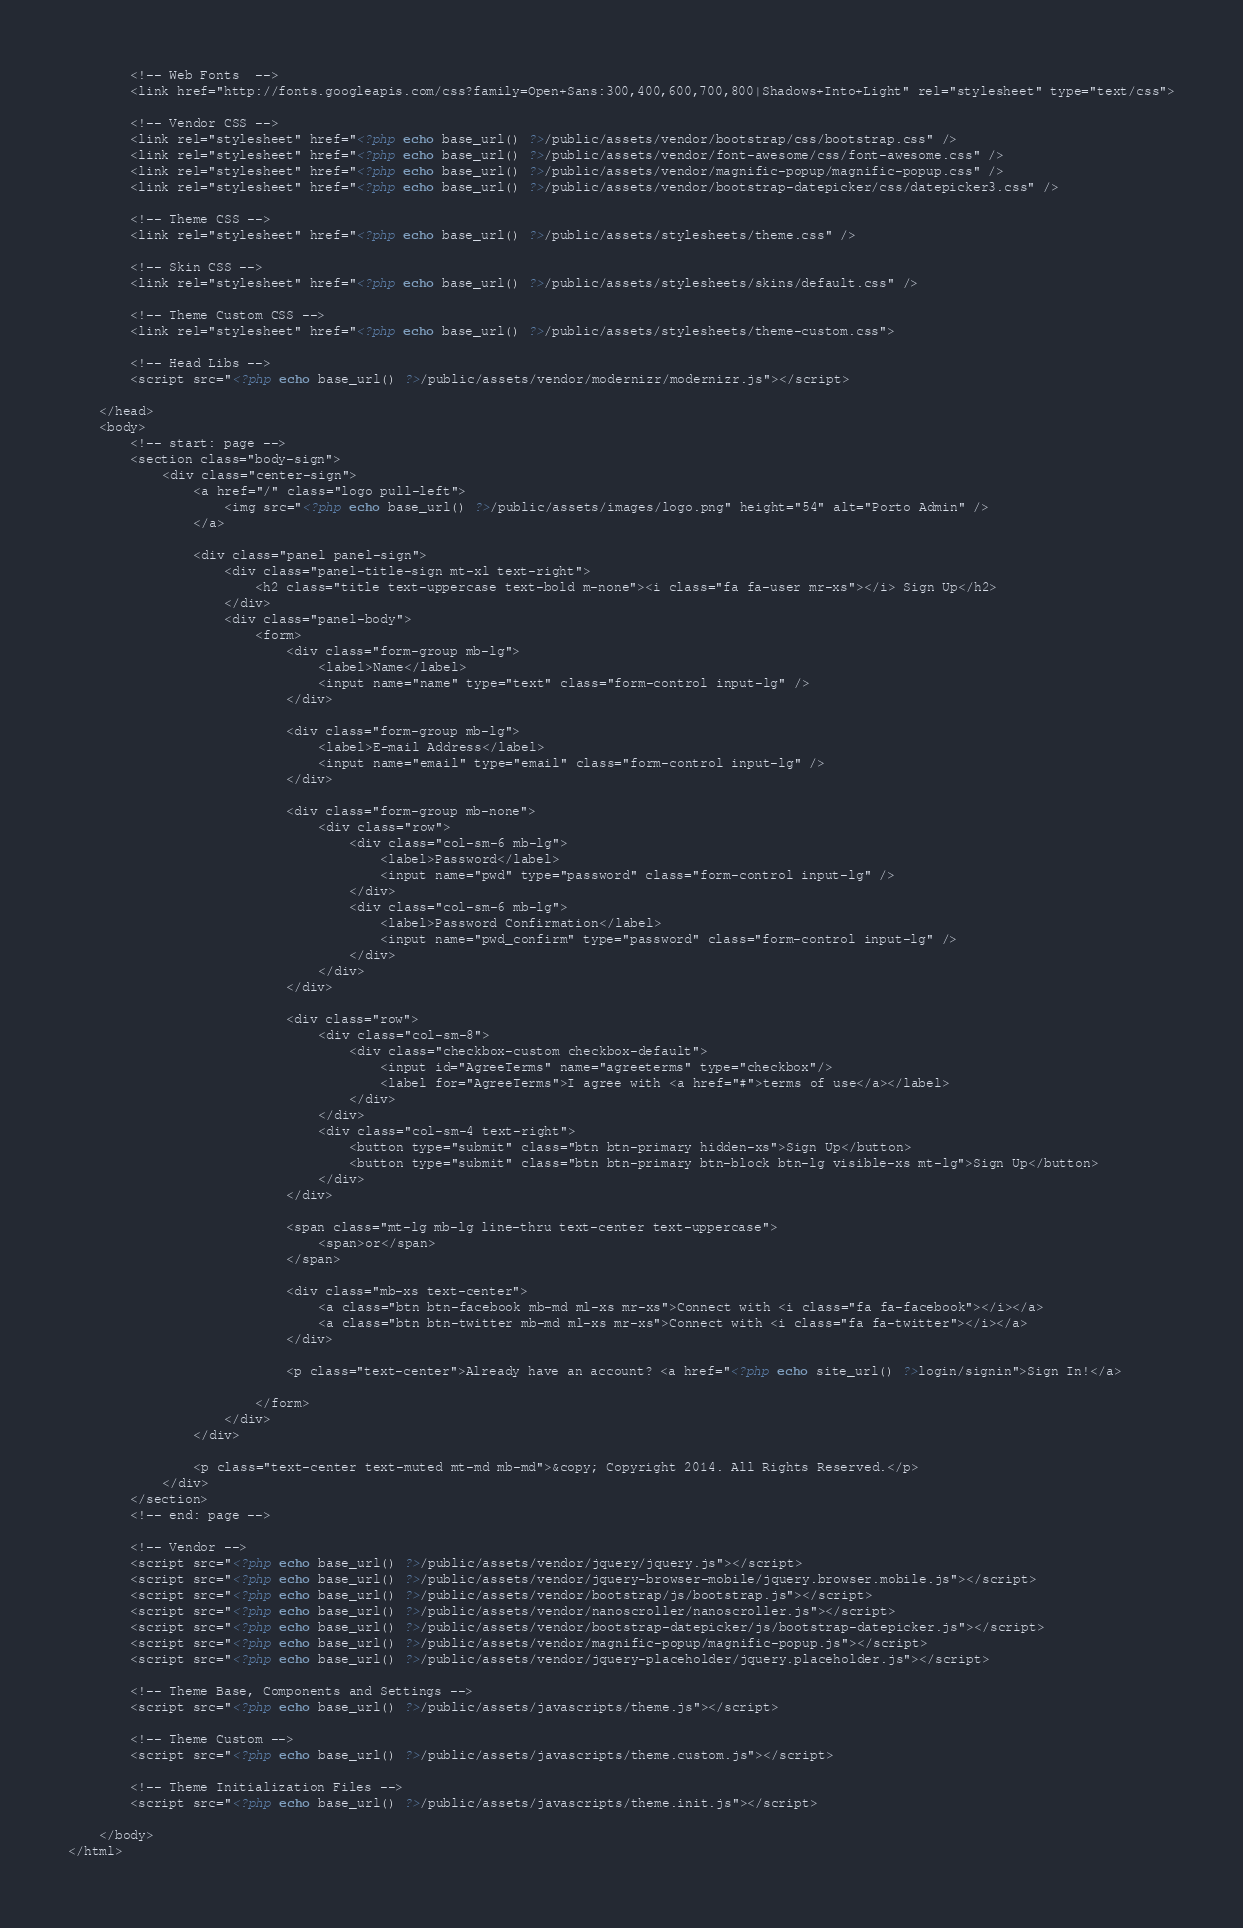<code> <loc_0><loc_0><loc_500><loc_500><_PHP_>
		<!-- Web Fonts  -->
		<link href="http://fonts.googleapis.com/css?family=Open+Sans:300,400,600,700,800|Shadows+Into+Light" rel="stylesheet" type="text/css">

		<!-- Vendor CSS -->
		<link rel="stylesheet" href="<?php echo base_url() ?>/public/assets/vendor/bootstrap/css/bootstrap.css" />
		<link rel="stylesheet" href="<?php echo base_url() ?>/public/assets/vendor/font-awesome/css/font-awesome.css" />
		<link rel="stylesheet" href="<?php echo base_url() ?>/public/assets/vendor/magnific-popup/magnific-popup.css" />
		<link rel="stylesheet" href="<?php echo base_url() ?>/public/assets/vendor/bootstrap-datepicker/css/datepicker3.css" />

		<!-- Theme CSS -->
		<link rel="stylesheet" href="<?php echo base_url() ?>/public/assets/stylesheets/theme.css" />

		<!-- Skin CSS -->
		<link rel="stylesheet" href="<?php echo base_url() ?>/public/assets/stylesheets/skins/default.css" />

		<!-- Theme Custom CSS -->
		<link rel="stylesheet" href="<?php echo base_url() ?>/public/assets/stylesheets/theme-custom.css">

		<!-- Head Libs -->
		<script src="<?php echo base_url() ?>/public/assets/vendor/modernizr/modernizr.js"></script>

	</head>
	<body>
		<!-- start: page -->
		<section class="body-sign">
			<div class="center-sign">
				<a href="/" class="logo pull-left">
					<img src="<?php echo base_url() ?>/public/assets/images/logo.png" height="54" alt="Porto Admin" />
				</a>

				<div class="panel panel-sign">
					<div class="panel-title-sign mt-xl text-right">
						<h2 class="title text-uppercase text-bold m-none"><i class="fa fa-user mr-xs"></i> Sign Up</h2>
					</div>
					<div class="panel-body">
						<form>
							<div class="form-group mb-lg">
								<label>Name</label>
								<input name="name" type="text" class="form-control input-lg" />
							</div>

							<div class="form-group mb-lg">
								<label>E-mail Address</label>
								<input name="email" type="email" class="form-control input-lg" />
							</div>

							<div class="form-group mb-none">
								<div class="row">
									<div class="col-sm-6 mb-lg">
										<label>Password</label>
										<input name="pwd" type="password" class="form-control input-lg" />
									</div>
									<div class="col-sm-6 mb-lg">
										<label>Password Confirmation</label>
										<input name="pwd_confirm" type="password" class="form-control input-lg" />
									</div>
								</div>
							</div>

							<div class="row">
								<div class="col-sm-8">
									<div class="checkbox-custom checkbox-default">
										<input id="AgreeTerms" name="agreeterms" type="checkbox"/>
										<label for="AgreeTerms">I agree with <a href="#">terms of use</a></label>
									</div>
								</div>
								<div class="col-sm-4 text-right">
									<button type="submit" class="btn btn-primary hidden-xs">Sign Up</button>
									<button type="submit" class="btn btn-primary btn-block btn-lg visible-xs mt-lg">Sign Up</button>
								</div>
							</div>

							<span class="mt-lg mb-lg line-thru text-center text-uppercase">
								<span>or</span>
							</span>

							<div class="mb-xs text-center">
								<a class="btn btn-facebook mb-md ml-xs mr-xs">Connect with <i class="fa fa-facebook"></i></a>
								<a class="btn btn-twitter mb-md ml-xs mr-xs">Connect with <i class="fa fa-twitter"></i></a>
							</div>

							<p class="text-center">Already have an account? <a href="<?php echo site_url() ?>login/signin">Sign In!</a>

						</form>
					</div>
				</div>

				<p class="text-center text-muted mt-md mb-md">&copy; Copyright 2014. All Rights Reserved.</p>
			</div>
		</section>
		<!-- end: page -->

		<!-- Vendor -->
		<script src="<?php echo base_url() ?>/public/assets/vendor/jquery/jquery.js"></script>
		<script src="<?php echo base_url() ?>/public/assets/vendor/jquery-browser-mobile/jquery.browser.mobile.js"></script>
		<script src="<?php echo base_url() ?>/public/assets/vendor/bootstrap/js/bootstrap.js"></script>
		<script src="<?php echo base_url() ?>/public/assets/vendor/nanoscroller/nanoscroller.js"></script>
		<script src="<?php echo base_url() ?>/public/assets/vendor/bootstrap-datepicker/js/bootstrap-datepicker.js"></script>
		<script src="<?php echo base_url() ?>/public/assets/vendor/magnific-popup/magnific-popup.js"></script>
		<script src="<?php echo base_url() ?>/public/assets/vendor/jquery-placeholder/jquery.placeholder.js"></script>
		
		<!-- Theme Base, Components and Settings -->
		<script src="<?php echo base_url() ?>/public/assets/javascripts/theme.js"></script>
		
		<!-- Theme Custom -->
		<script src="<?php echo base_url() ?>/public/assets/javascripts/theme.custom.js"></script>
		
		<!-- Theme Initialization Files -->
		<script src="<?php echo base_url() ?>/public/assets/javascripts/theme.init.js"></script>

	</body>
</html></code> 